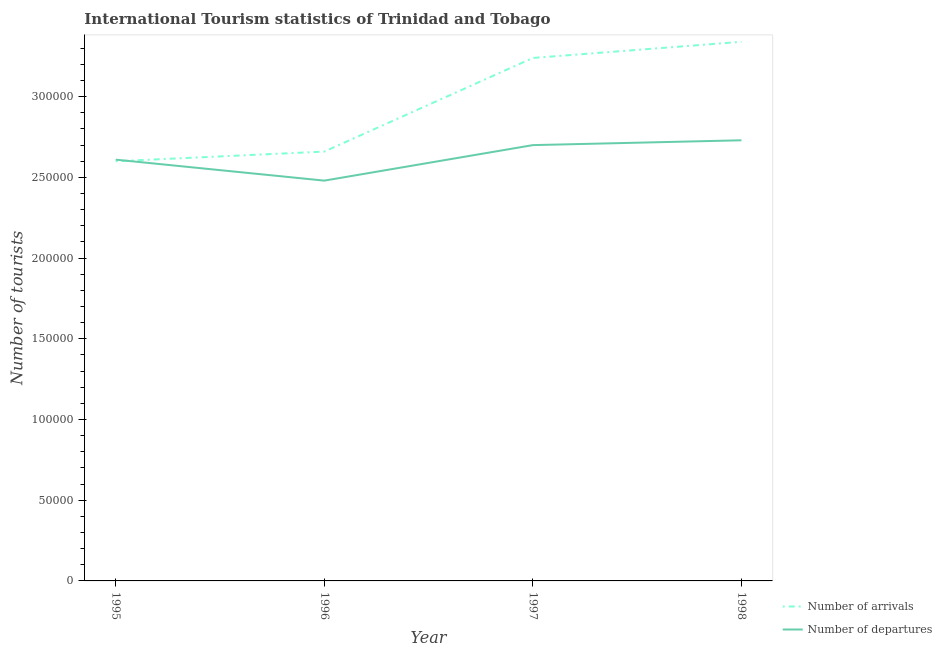Is the number of lines equal to the number of legend labels?
Your response must be concise. Yes. What is the number of tourist arrivals in 1996?
Keep it short and to the point. 2.66e+05. Across all years, what is the maximum number of tourist arrivals?
Make the answer very short. 3.34e+05. Across all years, what is the minimum number of tourist arrivals?
Provide a short and direct response. 2.60e+05. In which year was the number of tourist departures minimum?
Make the answer very short. 1996. What is the total number of tourist arrivals in the graph?
Provide a short and direct response. 1.18e+06. What is the difference between the number of tourist departures in 1996 and that in 1998?
Offer a very short reply. -2.50e+04. What is the difference between the number of tourist departures in 1998 and the number of tourist arrivals in 1997?
Give a very brief answer. -5.10e+04. What is the average number of tourist departures per year?
Ensure brevity in your answer.  2.63e+05. In the year 1996, what is the difference between the number of tourist arrivals and number of tourist departures?
Offer a very short reply. 1.80e+04. What is the ratio of the number of tourist departures in 1996 to that in 1997?
Your response must be concise. 0.92. Is the number of tourist departures in 1997 less than that in 1998?
Make the answer very short. Yes. What is the difference between the highest and the second highest number of tourist arrivals?
Make the answer very short. 10000. What is the difference between the highest and the lowest number of tourist arrivals?
Your answer should be very brief. 7.40e+04. In how many years, is the number of tourist arrivals greater than the average number of tourist arrivals taken over all years?
Make the answer very short. 2. Does the number of tourist arrivals monotonically increase over the years?
Your answer should be compact. Yes. Is the number of tourist departures strictly greater than the number of tourist arrivals over the years?
Ensure brevity in your answer.  No. Where does the legend appear in the graph?
Make the answer very short. Bottom right. What is the title of the graph?
Keep it short and to the point. International Tourism statistics of Trinidad and Tobago. What is the label or title of the Y-axis?
Keep it short and to the point. Number of tourists. What is the Number of tourists in Number of arrivals in 1995?
Provide a succinct answer. 2.60e+05. What is the Number of tourists in Number of departures in 1995?
Your answer should be compact. 2.61e+05. What is the Number of tourists in Number of arrivals in 1996?
Provide a succinct answer. 2.66e+05. What is the Number of tourists in Number of departures in 1996?
Offer a terse response. 2.48e+05. What is the Number of tourists of Number of arrivals in 1997?
Offer a terse response. 3.24e+05. What is the Number of tourists in Number of departures in 1997?
Keep it short and to the point. 2.70e+05. What is the Number of tourists of Number of arrivals in 1998?
Your answer should be compact. 3.34e+05. What is the Number of tourists of Number of departures in 1998?
Offer a very short reply. 2.73e+05. Across all years, what is the maximum Number of tourists of Number of arrivals?
Your response must be concise. 3.34e+05. Across all years, what is the maximum Number of tourists in Number of departures?
Ensure brevity in your answer.  2.73e+05. Across all years, what is the minimum Number of tourists in Number of arrivals?
Keep it short and to the point. 2.60e+05. Across all years, what is the minimum Number of tourists in Number of departures?
Your answer should be very brief. 2.48e+05. What is the total Number of tourists of Number of arrivals in the graph?
Give a very brief answer. 1.18e+06. What is the total Number of tourists of Number of departures in the graph?
Provide a short and direct response. 1.05e+06. What is the difference between the Number of tourists of Number of arrivals in 1995 and that in 1996?
Ensure brevity in your answer.  -6000. What is the difference between the Number of tourists in Number of departures in 1995 and that in 1996?
Your answer should be compact. 1.30e+04. What is the difference between the Number of tourists in Number of arrivals in 1995 and that in 1997?
Offer a very short reply. -6.40e+04. What is the difference between the Number of tourists in Number of departures in 1995 and that in 1997?
Offer a very short reply. -9000. What is the difference between the Number of tourists in Number of arrivals in 1995 and that in 1998?
Your answer should be compact. -7.40e+04. What is the difference between the Number of tourists in Number of departures in 1995 and that in 1998?
Provide a short and direct response. -1.20e+04. What is the difference between the Number of tourists of Number of arrivals in 1996 and that in 1997?
Make the answer very short. -5.80e+04. What is the difference between the Number of tourists in Number of departures in 1996 and that in 1997?
Ensure brevity in your answer.  -2.20e+04. What is the difference between the Number of tourists of Number of arrivals in 1996 and that in 1998?
Your response must be concise. -6.80e+04. What is the difference between the Number of tourists in Number of departures in 1996 and that in 1998?
Provide a short and direct response. -2.50e+04. What is the difference between the Number of tourists in Number of arrivals in 1997 and that in 1998?
Your answer should be very brief. -10000. What is the difference between the Number of tourists of Number of departures in 1997 and that in 1998?
Provide a succinct answer. -3000. What is the difference between the Number of tourists in Number of arrivals in 1995 and the Number of tourists in Number of departures in 1996?
Ensure brevity in your answer.  1.20e+04. What is the difference between the Number of tourists of Number of arrivals in 1995 and the Number of tourists of Number of departures in 1998?
Your answer should be compact. -1.30e+04. What is the difference between the Number of tourists in Number of arrivals in 1996 and the Number of tourists in Number of departures in 1997?
Make the answer very short. -4000. What is the difference between the Number of tourists in Number of arrivals in 1996 and the Number of tourists in Number of departures in 1998?
Your response must be concise. -7000. What is the difference between the Number of tourists of Number of arrivals in 1997 and the Number of tourists of Number of departures in 1998?
Your answer should be very brief. 5.10e+04. What is the average Number of tourists of Number of arrivals per year?
Offer a terse response. 2.96e+05. What is the average Number of tourists of Number of departures per year?
Your answer should be compact. 2.63e+05. In the year 1995, what is the difference between the Number of tourists in Number of arrivals and Number of tourists in Number of departures?
Your answer should be compact. -1000. In the year 1996, what is the difference between the Number of tourists of Number of arrivals and Number of tourists of Number of departures?
Your answer should be very brief. 1.80e+04. In the year 1997, what is the difference between the Number of tourists of Number of arrivals and Number of tourists of Number of departures?
Your answer should be very brief. 5.40e+04. In the year 1998, what is the difference between the Number of tourists in Number of arrivals and Number of tourists in Number of departures?
Make the answer very short. 6.10e+04. What is the ratio of the Number of tourists of Number of arrivals in 1995 to that in 1996?
Offer a very short reply. 0.98. What is the ratio of the Number of tourists in Number of departures in 1995 to that in 1996?
Offer a terse response. 1.05. What is the ratio of the Number of tourists in Number of arrivals in 1995 to that in 1997?
Your answer should be compact. 0.8. What is the ratio of the Number of tourists in Number of departures in 1995 to that in 1997?
Keep it short and to the point. 0.97. What is the ratio of the Number of tourists of Number of arrivals in 1995 to that in 1998?
Your answer should be very brief. 0.78. What is the ratio of the Number of tourists in Number of departures in 1995 to that in 1998?
Your answer should be compact. 0.96. What is the ratio of the Number of tourists of Number of arrivals in 1996 to that in 1997?
Offer a very short reply. 0.82. What is the ratio of the Number of tourists in Number of departures in 1996 to that in 1997?
Offer a terse response. 0.92. What is the ratio of the Number of tourists of Number of arrivals in 1996 to that in 1998?
Offer a very short reply. 0.8. What is the ratio of the Number of tourists in Number of departures in 1996 to that in 1998?
Provide a succinct answer. 0.91. What is the ratio of the Number of tourists in Number of arrivals in 1997 to that in 1998?
Offer a terse response. 0.97. What is the ratio of the Number of tourists in Number of departures in 1997 to that in 1998?
Make the answer very short. 0.99. What is the difference between the highest and the second highest Number of tourists in Number of departures?
Your response must be concise. 3000. What is the difference between the highest and the lowest Number of tourists of Number of arrivals?
Your answer should be very brief. 7.40e+04. What is the difference between the highest and the lowest Number of tourists of Number of departures?
Give a very brief answer. 2.50e+04. 